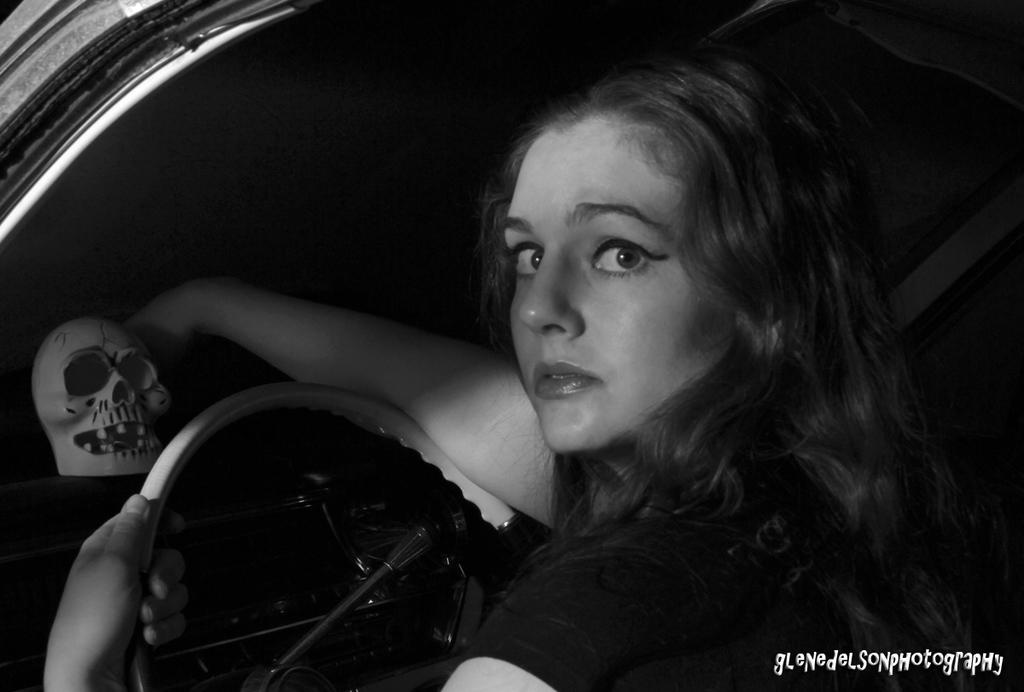Who is the main subject in the image? There is a woman in the image. What is the woman doing in the image? The woman is driving a vehicle. What controls the direction of the vehicle in the image? There is a steering wheel in the image. What additional detail can be observed in the image? There is a skeleton face in the image. What type of sweater is the woman wearing in the image? There is no sweater visible in the image; the woman is driving a vehicle. What kind of juice can be seen in the image? There is no juice present in the image. 